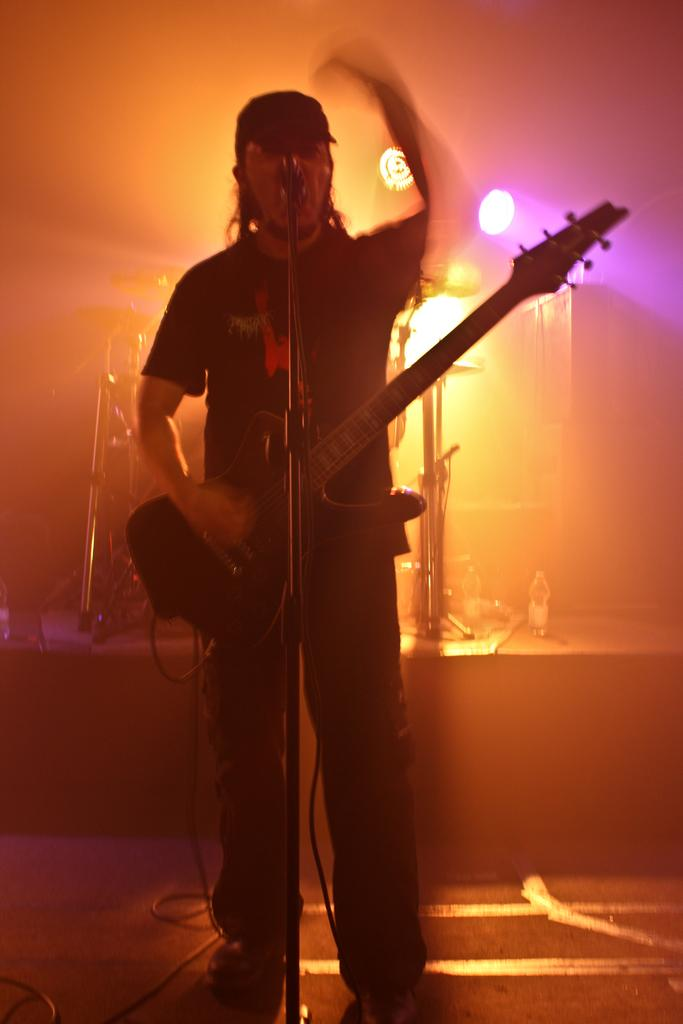What is the man in the center of the image doing? The man is standing in the center of the image and holding a guitar. What object is in front of the man? There is a microphone in front of the man. What can be seen in the background of the image? There are lights and musical instruments visible in the background. What type of advice can be heard coming from the tub in the image? There is no tub present in the image, so no advice can be heard coming from it. 